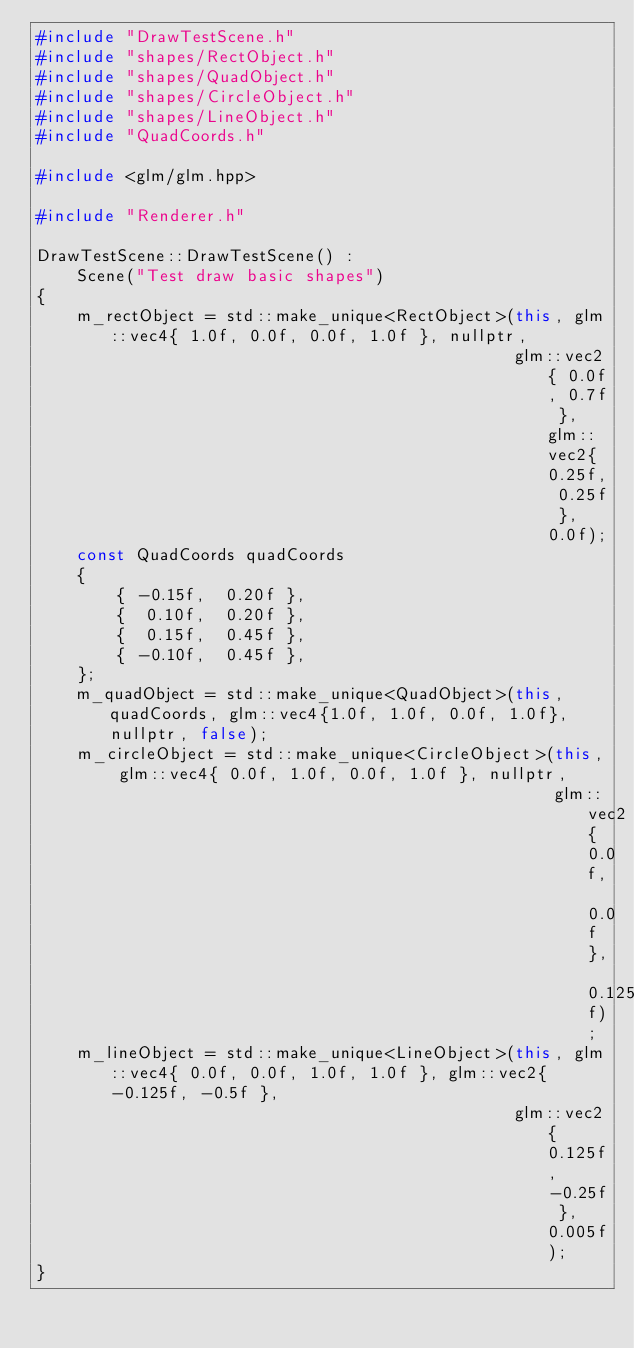<code> <loc_0><loc_0><loc_500><loc_500><_C++_>#include "DrawTestScene.h"
#include "shapes/RectObject.h"
#include "shapes/QuadObject.h"
#include "shapes/CircleObject.h"
#include "shapes/LineObject.h"
#include "QuadCoords.h"

#include <glm/glm.hpp>

#include "Renderer.h"

DrawTestScene::DrawTestScene() :
    Scene("Test draw basic shapes")
{
    m_rectObject = std::make_unique<RectObject>(this, glm::vec4{ 1.0f, 0.0f, 0.0f, 1.0f }, nullptr,
                                                glm::vec2{ 0.0f, 0.7f }, glm::vec2{ 0.25f, 0.25f }, 0.0f);
    const QuadCoords quadCoords
    {
        { -0.15f,  0.20f },
        {  0.10f,  0.20f },
        {  0.15f,  0.45f },
        { -0.10f,  0.45f },
    };
    m_quadObject = std::make_unique<QuadObject>(this, quadCoords, glm::vec4{1.0f, 1.0f, 0.0f, 1.0f}, nullptr, false);
    m_circleObject = std::make_unique<CircleObject>(this, glm::vec4{ 0.0f, 1.0f, 0.0f, 1.0f }, nullptr,
                                                    glm::vec2{ 0.0f, 0.0f }, 0.125f);
    m_lineObject = std::make_unique<LineObject>(this, glm::vec4{ 0.0f, 0.0f, 1.0f, 1.0f }, glm::vec2{ -0.125f, -0.5f },
                                                glm::vec2{ 0.125f, -0.25f }, 0.005f);
}
</code> 